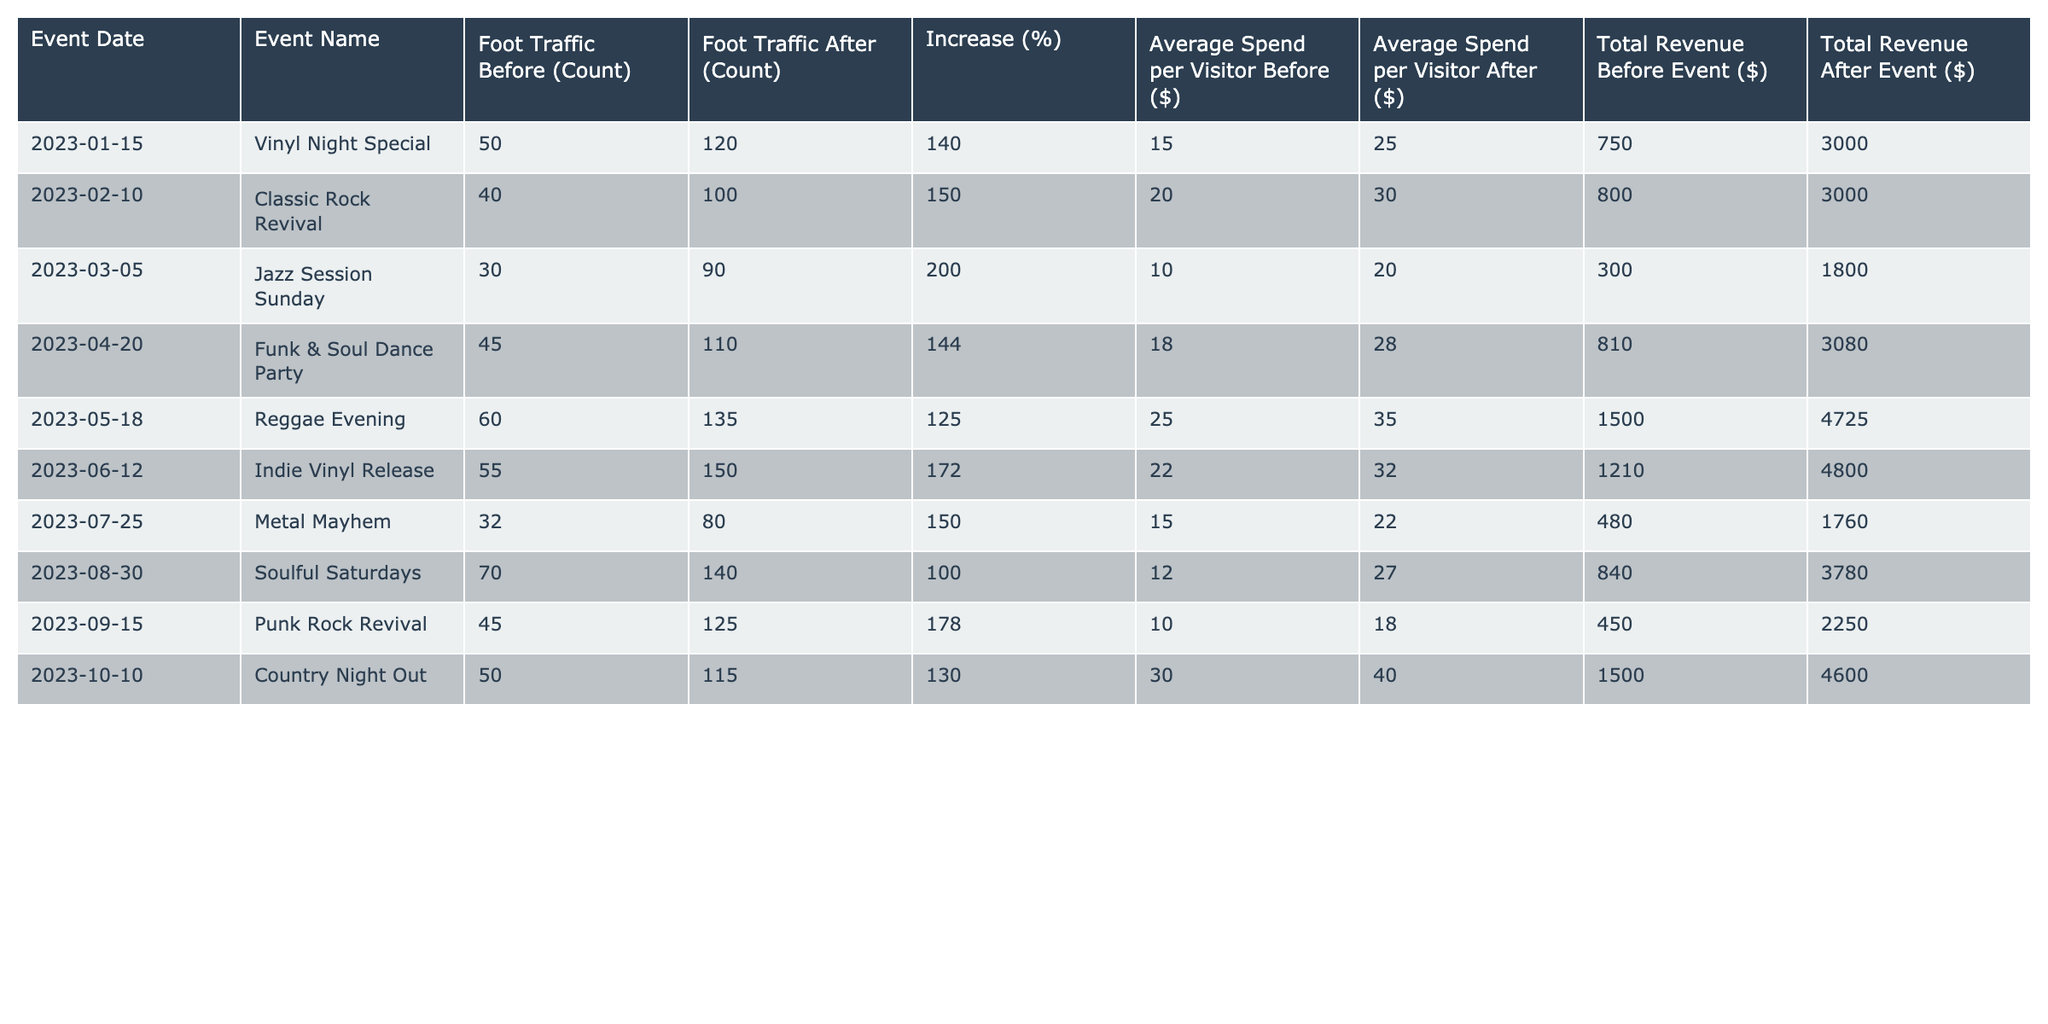What was the foot traffic increase for the "Funk & Soul Dance Party" event? The foot traffic before the event was 45, and after it was 110. The increase is calculated as (110 - 45) = 65, resulting in a percentage increase of (65/45) * 100 = 144%.
Answer: 144% Which event had the highest total revenue after the event? Reviewing the total revenue after each event, the "Reggae Evening" had the highest total revenue of $4725.
Answer: $4725 True or False: The average spend per visitor increased for every event listed. Analyzing the average spend for each event, we see that the average spend before the "Jazz Session Sunday" (10) is greater than after (20), indicating a decrease. Therefore, the statement is False.
Answer: False What is the average foot traffic increase across all events? Summing up the increases gives (140 + 150 + 200 + 144 + 125 + 172 + 150 + 100 + 178 + 130) = 1360, and dividing by the number of events (10) leads to an average increase of 1360 / 10 = 136%.
Answer: 136% Which event had the lowest average spend per visitor before the event? Looking at the average spends before each event, "Jazz Session Sunday" has the lowest average spend per visitor at $10.
Answer: $10 What was the difference in total revenue before and after the "Vinyl Night Special"? The total revenue before the event was $750 and after it was $3000. The difference is calculated as ($3000 - $750) = $2250.
Answer: $2250 Are there more events with an increase of 150% or more in foot traffic after the events? Counting those events, we see "Vinyl Night Special," "Classic Rock Revival," "Jazz Session Sunday," "Funk & Soul Dance Party," "Reggae Evening," "Indie Vinyl Release," "Punk Rock Revival," and "Country Night Out" total to seven events. Therefore, there are more events with at least 150% increase in foot traffic.
Answer: Yes What was the total revenue before all events combined? Adding total revenues before each event gives $750 + $800 + $300 + $810 + $1500 + $1210 + $480 + $840 + $450 + $1500 = $5880.
Answer: $5880 Which month had the event with the least amount of foot traffic? The event with the least foot traffic before is "Jazz Session Sunday" in March, having only 30 visitors.
Answer: March Calculate the percentage increase from the lowest to the highest foot traffic after an event. The lowest foot traffic after an event is 80 from "Metal Mayhem," and the highest is 150 from "Indie Vinyl Release." The percentage increase is calculated as ((150 - 80) / 80) * 100 = 87.5%.
Answer: 87.5% 